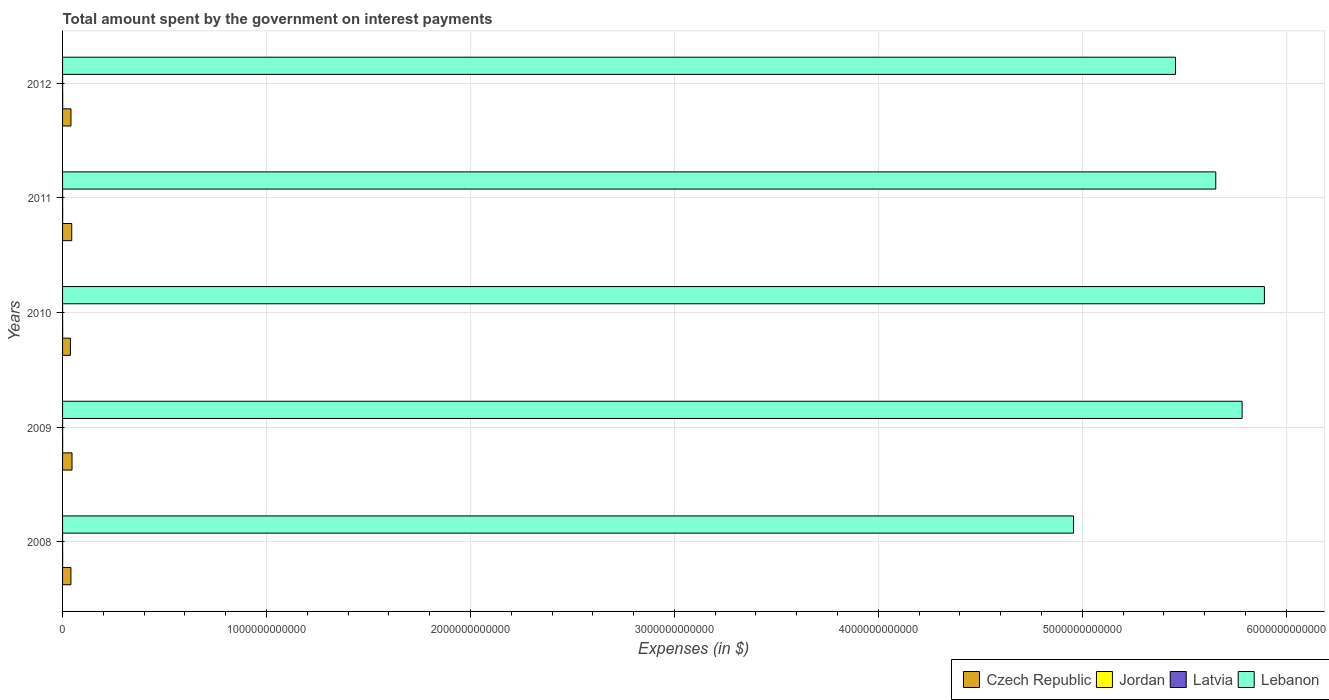How many different coloured bars are there?
Make the answer very short. 4. Are the number of bars on each tick of the Y-axis equal?
Make the answer very short. Yes. How many bars are there on the 1st tick from the bottom?
Offer a terse response. 4. In how many cases, is the number of bars for a given year not equal to the number of legend labels?
Keep it short and to the point. 0. What is the amount spent on interest payments by the government in Jordan in 2010?
Your answer should be compact. 3.98e+08. Across all years, what is the maximum amount spent on interest payments by the government in Latvia?
Offer a very short reply. 2.15e+08. Across all years, what is the minimum amount spent on interest payments by the government in Lebanon?
Give a very brief answer. 4.96e+12. In which year was the amount spent on interest payments by the government in Lebanon maximum?
Your answer should be very brief. 2010. What is the total amount spent on interest payments by the government in Jordan in the graph?
Provide a short and direct response. 2.18e+09. What is the difference between the amount spent on interest payments by the government in Latvia in 2011 and that in 2012?
Keep it short and to the point. -2.36e+07. What is the difference between the amount spent on interest payments by the government in Latvia in 2008 and the amount spent on interest payments by the government in Czech Republic in 2012?
Provide a succinct answer. -4.11e+1. What is the average amount spent on interest payments by the government in Latvia per year?
Ensure brevity in your answer.  1.56e+08. In the year 2008, what is the difference between the amount spent on interest payments by the government in Jordan and amount spent on interest payments by the government in Lebanon?
Provide a short and direct response. -4.96e+12. What is the ratio of the amount spent on interest payments by the government in Latvia in 2008 to that in 2010?
Offer a very short reply. 0.35. Is the difference between the amount spent on interest payments by the government in Jordan in 2009 and 2010 greater than the difference between the amount spent on interest payments by the government in Lebanon in 2009 and 2010?
Your response must be concise. Yes. What is the difference between the highest and the second highest amount spent on interest payments by the government in Latvia?
Give a very brief answer. 2.36e+07. What is the difference between the highest and the lowest amount spent on interest payments by the government in Lebanon?
Provide a short and direct response. 9.36e+11. In how many years, is the amount spent on interest payments by the government in Latvia greater than the average amount spent on interest payments by the government in Latvia taken over all years?
Provide a succinct answer. 3. Is the sum of the amount spent on interest payments by the government in Latvia in 2010 and 2012 greater than the maximum amount spent on interest payments by the government in Lebanon across all years?
Offer a very short reply. No. What does the 4th bar from the top in 2010 represents?
Offer a terse response. Czech Republic. What does the 4th bar from the bottom in 2009 represents?
Offer a terse response. Lebanon. Is it the case that in every year, the sum of the amount spent on interest payments by the government in Latvia and amount spent on interest payments by the government in Czech Republic is greater than the amount spent on interest payments by the government in Jordan?
Give a very brief answer. Yes. Are all the bars in the graph horizontal?
Ensure brevity in your answer.  Yes. What is the difference between two consecutive major ticks on the X-axis?
Your answer should be compact. 1.00e+12. Are the values on the major ticks of X-axis written in scientific E-notation?
Offer a very short reply. No. Does the graph contain grids?
Your answer should be compact. Yes. Where does the legend appear in the graph?
Offer a terse response. Bottom right. How many legend labels are there?
Your answer should be compact. 4. What is the title of the graph?
Make the answer very short. Total amount spent by the government on interest payments. Does "Macedonia" appear as one of the legend labels in the graph?
Your response must be concise. No. What is the label or title of the X-axis?
Make the answer very short. Expenses (in $). What is the Expenses (in $) in Czech Republic in 2008?
Your answer should be very brief. 4.09e+1. What is the Expenses (in $) of Jordan in 2008?
Your answer should be compact. 3.78e+08. What is the Expenses (in $) of Latvia in 2008?
Make the answer very short. 5.90e+07. What is the Expenses (in $) in Lebanon in 2008?
Offer a very short reply. 4.96e+12. What is the Expenses (in $) of Czech Republic in 2009?
Your answer should be compact. 4.64e+1. What is the Expenses (in $) of Jordan in 2009?
Your answer should be compact. 3.92e+08. What is the Expenses (in $) in Latvia in 2009?
Keep it short and to the point. 1.44e+08. What is the Expenses (in $) of Lebanon in 2009?
Your response must be concise. 5.78e+12. What is the Expenses (in $) of Czech Republic in 2010?
Offer a very short reply. 3.85e+1. What is the Expenses (in $) of Jordan in 2010?
Offer a terse response. 3.98e+08. What is the Expenses (in $) in Latvia in 2010?
Offer a terse response. 1.70e+08. What is the Expenses (in $) in Lebanon in 2010?
Offer a terse response. 5.89e+12. What is the Expenses (in $) in Czech Republic in 2011?
Provide a succinct answer. 4.50e+1. What is the Expenses (in $) in Jordan in 2011?
Give a very brief answer. 4.30e+08. What is the Expenses (in $) of Latvia in 2011?
Offer a terse response. 1.91e+08. What is the Expenses (in $) of Lebanon in 2011?
Keep it short and to the point. 5.65e+12. What is the Expenses (in $) of Czech Republic in 2012?
Keep it short and to the point. 4.12e+1. What is the Expenses (in $) in Jordan in 2012?
Ensure brevity in your answer.  5.83e+08. What is the Expenses (in $) of Latvia in 2012?
Provide a short and direct response. 2.15e+08. What is the Expenses (in $) in Lebanon in 2012?
Keep it short and to the point. 5.46e+12. Across all years, what is the maximum Expenses (in $) in Czech Republic?
Offer a terse response. 4.64e+1. Across all years, what is the maximum Expenses (in $) in Jordan?
Give a very brief answer. 5.83e+08. Across all years, what is the maximum Expenses (in $) in Latvia?
Your response must be concise. 2.15e+08. Across all years, what is the maximum Expenses (in $) in Lebanon?
Make the answer very short. 5.89e+12. Across all years, what is the minimum Expenses (in $) in Czech Republic?
Provide a succinct answer. 3.85e+1. Across all years, what is the minimum Expenses (in $) in Jordan?
Your response must be concise. 3.78e+08. Across all years, what is the minimum Expenses (in $) in Latvia?
Ensure brevity in your answer.  5.90e+07. Across all years, what is the minimum Expenses (in $) in Lebanon?
Give a very brief answer. 4.96e+12. What is the total Expenses (in $) of Czech Republic in the graph?
Keep it short and to the point. 2.12e+11. What is the total Expenses (in $) in Jordan in the graph?
Give a very brief answer. 2.18e+09. What is the total Expenses (in $) of Latvia in the graph?
Your answer should be very brief. 7.79e+08. What is the total Expenses (in $) of Lebanon in the graph?
Your answer should be compact. 2.77e+13. What is the difference between the Expenses (in $) of Czech Republic in 2008 and that in 2009?
Make the answer very short. -5.42e+09. What is the difference between the Expenses (in $) in Jordan in 2008 and that in 2009?
Offer a very short reply. -1.44e+07. What is the difference between the Expenses (in $) in Latvia in 2008 and that in 2009?
Your answer should be very brief. -8.50e+07. What is the difference between the Expenses (in $) of Lebanon in 2008 and that in 2009?
Give a very brief answer. -8.27e+11. What is the difference between the Expenses (in $) in Czech Republic in 2008 and that in 2010?
Your answer should be very brief. 2.45e+09. What is the difference between the Expenses (in $) of Jordan in 2008 and that in 2010?
Your answer should be very brief. -1.97e+07. What is the difference between the Expenses (in $) in Latvia in 2008 and that in 2010?
Your answer should be very brief. -1.11e+08. What is the difference between the Expenses (in $) of Lebanon in 2008 and that in 2010?
Provide a succinct answer. -9.36e+11. What is the difference between the Expenses (in $) of Czech Republic in 2008 and that in 2011?
Provide a succinct answer. -4.04e+09. What is the difference between the Expenses (in $) in Jordan in 2008 and that in 2011?
Make the answer very short. -5.17e+07. What is the difference between the Expenses (in $) in Latvia in 2008 and that in 2011?
Keep it short and to the point. -1.32e+08. What is the difference between the Expenses (in $) of Lebanon in 2008 and that in 2011?
Your answer should be compact. -6.97e+11. What is the difference between the Expenses (in $) in Czech Republic in 2008 and that in 2012?
Your answer should be compact. -2.34e+08. What is the difference between the Expenses (in $) in Jordan in 2008 and that in 2012?
Offer a very short reply. -2.05e+08. What is the difference between the Expenses (in $) in Latvia in 2008 and that in 2012?
Your response must be concise. -1.56e+08. What is the difference between the Expenses (in $) of Lebanon in 2008 and that in 2012?
Provide a short and direct response. -5.00e+11. What is the difference between the Expenses (in $) of Czech Republic in 2009 and that in 2010?
Keep it short and to the point. 7.87e+09. What is the difference between the Expenses (in $) of Jordan in 2009 and that in 2010?
Your answer should be very brief. -5.30e+06. What is the difference between the Expenses (in $) in Latvia in 2009 and that in 2010?
Offer a very short reply. -2.62e+07. What is the difference between the Expenses (in $) of Lebanon in 2009 and that in 2010?
Provide a short and direct response. -1.09e+11. What is the difference between the Expenses (in $) of Czech Republic in 2009 and that in 2011?
Keep it short and to the point. 1.38e+09. What is the difference between the Expenses (in $) of Jordan in 2009 and that in 2011?
Give a very brief answer. -3.73e+07. What is the difference between the Expenses (in $) in Latvia in 2009 and that in 2011?
Make the answer very short. -4.69e+07. What is the difference between the Expenses (in $) in Lebanon in 2009 and that in 2011?
Your answer should be very brief. 1.29e+11. What is the difference between the Expenses (in $) in Czech Republic in 2009 and that in 2012?
Offer a terse response. 5.19e+09. What is the difference between the Expenses (in $) of Jordan in 2009 and that in 2012?
Offer a terse response. -1.91e+08. What is the difference between the Expenses (in $) in Latvia in 2009 and that in 2012?
Make the answer very short. -7.05e+07. What is the difference between the Expenses (in $) in Lebanon in 2009 and that in 2012?
Your answer should be compact. 3.27e+11. What is the difference between the Expenses (in $) of Czech Republic in 2010 and that in 2011?
Provide a short and direct response. -6.49e+09. What is the difference between the Expenses (in $) of Jordan in 2010 and that in 2011?
Your answer should be compact. -3.20e+07. What is the difference between the Expenses (in $) in Latvia in 2010 and that in 2011?
Your answer should be very brief. -2.07e+07. What is the difference between the Expenses (in $) of Lebanon in 2010 and that in 2011?
Provide a short and direct response. 2.38e+11. What is the difference between the Expenses (in $) in Czech Republic in 2010 and that in 2012?
Ensure brevity in your answer.  -2.69e+09. What is the difference between the Expenses (in $) of Jordan in 2010 and that in 2012?
Your answer should be compact. -1.86e+08. What is the difference between the Expenses (in $) of Latvia in 2010 and that in 2012?
Keep it short and to the point. -4.43e+07. What is the difference between the Expenses (in $) in Lebanon in 2010 and that in 2012?
Your answer should be compact. 4.36e+11. What is the difference between the Expenses (in $) in Czech Republic in 2011 and that in 2012?
Give a very brief answer. 3.81e+09. What is the difference between the Expenses (in $) of Jordan in 2011 and that in 2012?
Your answer should be compact. -1.54e+08. What is the difference between the Expenses (in $) of Latvia in 2011 and that in 2012?
Your answer should be compact. -2.36e+07. What is the difference between the Expenses (in $) of Lebanon in 2011 and that in 2012?
Offer a very short reply. 1.98e+11. What is the difference between the Expenses (in $) of Czech Republic in 2008 and the Expenses (in $) of Jordan in 2009?
Provide a succinct answer. 4.06e+1. What is the difference between the Expenses (in $) of Czech Republic in 2008 and the Expenses (in $) of Latvia in 2009?
Your response must be concise. 4.08e+1. What is the difference between the Expenses (in $) in Czech Republic in 2008 and the Expenses (in $) in Lebanon in 2009?
Provide a succinct answer. -5.74e+12. What is the difference between the Expenses (in $) of Jordan in 2008 and the Expenses (in $) of Latvia in 2009?
Provide a short and direct response. 2.34e+08. What is the difference between the Expenses (in $) in Jordan in 2008 and the Expenses (in $) in Lebanon in 2009?
Your answer should be compact. -5.78e+12. What is the difference between the Expenses (in $) of Latvia in 2008 and the Expenses (in $) of Lebanon in 2009?
Ensure brevity in your answer.  -5.78e+12. What is the difference between the Expenses (in $) of Czech Republic in 2008 and the Expenses (in $) of Jordan in 2010?
Give a very brief answer. 4.05e+1. What is the difference between the Expenses (in $) in Czech Republic in 2008 and the Expenses (in $) in Latvia in 2010?
Your response must be concise. 4.08e+1. What is the difference between the Expenses (in $) in Czech Republic in 2008 and the Expenses (in $) in Lebanon in 2010?
Offer a very short reply. -5.85e+12. What is the difference between the Expenses (in $) in Jordan in 2008 and the Expenses (in $) in Latvia in 2010?
Provide a succinct answer. 2.08e+08. What is the difference between the Expenses (in $) in Jordan in 2008 and the Expenses (in $) in Lebanon in 2010?
Your response must be concise. -5.89e+12. What is the difference between the Expenses (in $) of Latvia in 2008 and the Expenses (in $) of Lebanon in 2010?
Provide a succinct answer. -5.89e+12. What is the difference between the Expenses (in $) in Czech Republic in 2008 and the Expenses (in $) in Jordan in 2011?
Your answer should be very brief. 4.05e+1. What is the difference between the Expenses (in $) of Czech Republic in 2008 and the Expenses (in $) of Latvia in 2011?
Your answer should be compact. 4.08e+1. What is the difference between the Expenses (in $) of Czech Republic in 2008 and the Expenses (in $) of Lebanon in 2011?
Provide a short and direct response. -5.61e+12. What is the difference between the Expenses (in $) of Jordan in 2008 and the Expenses (in $) of Latvia in 2011?
Your answer should be very brief. 1.87e+08. What is the difference between the Expenses (in $) in Jordan in 2008 and the Expenses (in $) in Lebanon in 2011?
Provide a short and direct response. -5.65e+12. What is the difference between the Expenses (in $) of Latvia in 2008 and the Expenses (in $) of Lebanon in 2011?
Ensure brevity in your answer.  -5.65e+12. What is the difference between the Expenses (in $) in Czech Republic in 2008 and the Expenses (in $) in Jordan in 2012?
Provide a short and direct response. 4.04e+1. What is the difference between the Expenses (in $) in Czech Republic in 2008 and the Expenses (in $) in Latvia in 2012?
Your answer should be very brief. 4.07e+1. What is the difference between the Expenses (in $) of Czech Republic in 2008 and the Expenses (in $) of Lebanon in 2012?
Your answer should be very brief. -5.42e+12. What is the difference between the Expenses (in $) of Jordan in 2008 and the Expenses (in $) of Latvia in 2012?
Give a very brief answer. 1.63e+08. What is the difference between the Expenses (in $) of Jordan in 2008 and the Expenses (in $) of Lebanon in 2012?
Ensure brevity in your answer.  -5.46e+12. What is the difference between the Expenses (in $) in Latvia in 2008 and the Expenses (in $) in Lebanon in 2012?
Your answer should be very brief. -5.46e+12. What is the difference between the Expenses (in $) in Czech Republic in 2009 and the Expenses (in $) in Jordan in 2010?
Keep it short and to the point. 4.60e+1. What is the difference between the Expenses (in $) in Czech Republic in 2009 and the Expenses (in $) in Latvia in 2010?
Keep it short and to the point. 4.62e+1. What is the difference between the Expenses (in $) of Czech Republic in 2009 and the Expenses (in $) of Lebanon in 2010?
Provide a short and direct response. -5.85e+12. What is the difference between the Expenses (in $) in Jordan in 2009 and the Expenses (in $) in Latvia in 2010?
Your answer should be compact. 2.22e+08. What is the difference between the Expenses (in $) in Jordan in 2009 and the Expenses (in $) in Lebanon in 2010?
Your answer should be very brief. -5.89e+12. What is the difference between the Expenses (in $) in Latvia in 2009 and the Expenses (in $) in Lebanon in 2010?
Your response must be concise. -5.89e+12. What is the difference between the Expenses (in $) in Czech Republic in 2009 and the Expenses (in $) in Jordan in 2011?
Give a very brief answer. 4.59e+1. What is the difference between the Expenses (in $) in Czech Republic in 2009 and the Expenses (in $) in Latvia in 2011?
Keep it short and to the point. 4.62e+1. What is the difference between the Expenses (in $) in Czech Republic in 2009 and the Expenses (in $) in Lebanon in 2011?
Offer a very short reply. -5.61e+12. What is the difference between the Expenses (in $) in Jordan in 2009 and the Expenses (in $) in Latvia in 2011?
Keep it short and to the point. 2.01e+08. What is the difference between the Expenses (in $) in Jordan in 2009 and the Expenses (in $) in Lebanon in 2011?
Keep it short and to the point. -5.65e+12. What is the difference between the Expenses (in $) of Latvia in 2009 and the Expenses (in $) of Lebanon in 2011?
Keep it short and to the point. -5.65e+12. What is the difference between the Expenses (in $) of Czech Republic in 2009 and the Expenses (in $) of Jordan in 2012?
Give a very brief answer. 4.58e+1. What is the difference between the Expenses (in $) in Czech Republic in 2009 and the Expenses (in $) in Latvia in 2012?
Your response must be concise. 4.62e+1. What is the difference between the Expenses (in $) of Czech Republic in 2009 and the Expenses (in $) of Lebanon in 2012?
Offer a terse response. -5.41e+12. What is the difference between the Expenses (in $) of Jordan in 2009 and the Expenses (in $) of Latvia in 2012?
Keep it short and to the point. 1.78e+08. What is the difference between the Expenses (in $) in Jordan in 2009 and the Expenses (in $) in Lebanon in 2012?
Give a very brief answer. -5.46e+12. What is the difference between the Expenses (in $) in Latvia in 2009 and the Expenses (in $) in Lebanon in 2012?
Ensure brevity in your answer.  -5.46e+12. What is the difference between the Expenses (in $) in Czech Republic in 2010 and the Expenses (in $) in Jordan in 2011?
Give a very brief answer. 3.81e+1. What is the difference between the Expenses (in $) of Czech Republic in 2010 and the Expenses (in $) of Latvia in 2011?
Provide a succinct answer. 3.83e+1. What is the difference between the Expenses (in $) of Czech Republic in 2010 and the Expenses (in $) of Lebanon in 2011?
Ensure brevity in your answer.  -5.62e+12. What is the difference between the Expenses (in $) in Jordan in 2010 and the Expenses (in $) in Latvia in 2011?
Your answer should be compact. 2.07e+08. What is the difference between the Expenses (in $) in Jordan in 2010 and the Expenses (in $) in Lebanon in 2011?
Offer a terse response. -5.65e+12. What is the difference between the Expenses (in $) in Latvia in 2010 and the Expenses (in $) in Lebanon in 2011?
Give a very brief answer. -5.65e+12. What is the difference between the Expenses (in $) of Czech Republic in 2010 and the Expenses (in $) of Jordan in 2012?
Provide a short and direct response. 3.79e+1. What is the difference between the Expenses (in $) of Czech Republic in 2010 and the Expenses (in $) of Latvia in 2012?
Make the answer very short. 3.83e+1. What is the difference between the Expenses (in $) of Czech Republic in 2010 and the Expenses (in $) of Lebanon in 2012?
Your answer should be very brief. -5.42e+12. What is the difference between the Expenses (in $) in Jordan in 2010 and the Expenses (in $) in Latvia in 2012?
Give a very brief answer. 1.83e+08. What is the difference between the Expenses (in $) of Jordan in 2010 and the Expenses (in $) of Lebanon in 2012?
Your answer should be very brief. -5.46e+12. What is the difference between the Expenses (in $) in Latvia in 2010 and the Expenses (in $) in Lebanon in 2012?
Your answer should be very brief. -5.46e+12. What is the difference between the Expenses (in $) in Czech Republic in 2011 and the Expenses (in $) in Jordan in 2012?
Keep it short and to the point. 4.44e+1. What is the difference between the Expenses (in $) in Czech Republic in 2011 and the Expenses (in $) in Latvia in 2012?
Give a very brief answer. 4.48e+1. What is the difference between the Expenses (in $) of Czech Republic in 2011 and the Expenses (in $) of Lebanon in 2012?
Make the answer very short. -5.41e+12. What is the difference between the Expenses (in $) of Jordan in 2011 and the Expenses (in $) of Latvia in 2012?
Make the answer very short. 2.15e+08. What is the difference between the Expenses (in $) in Jordan in 2011 and the Expenses (in $) in Lebanon in 2012?
Your answer should be compact. -5.46e+12. What is the difference between the Expenses (in $) of Latvia in 2011 and the Expenses (in $) of Lebanon in 2012?
Ensure brevity in your answer.  -5.46e+12. What is the average Expenses (in $) in Czech Republic per year?
Keep it short and to the point. 4.24e+1. What is the average Expenses (in $) of Jordan per year?
Keep it short and to the point. 4.36e+08. What is the average Expenses (in $) in Latvia per year?
Your response must be concise. 1.56e+08. What is the average Expenses (in $) in Lebanon per year?
Keep it short and to the point. 5.55e+12. In the year 2008, what is the difference between the Expenses (in $) of Czech Republic and Expenses (in $) of Jordan?
Provide a short and direct response. 4.06e+1. In the year 2008, what is the difference between the Expenses (in $) in Czech Republic and Expenses (in $) in Latvia?
Keep it short and to the point. 4.09e+1. In the year 2008, what is the difference between the Expenses (in $) in Czech Republic and Expenses (in $) in Lebanon?
Offer a very short reply. -4.92e+12. In the year 2008, what is the difference between the Expenses (in $) of Jordan and Expenses (in $) of Latvia?
Give a very brief answer. 3.19e+08. In the year 2008, what is the difference between the Expenses (in $) in Jordan and Expenses (in $) in Lebanon?
Make the answer very short. -4.96e+12. In the year 2008, what is the difference between the Expenses (in $) of Latvia and Expenses (in $) of Lebanon?
Make the answer very short. -4.96e+12. In the year 2009, what is the difference between the Expenses (in $) of Czech Republic and Expenses (in $) of Jordan?
Ensure brevity in your answer.  4.60e+1. In the year 2009, what is the difference between the Expenses (in $) in Czech Republic and Expenses (in $) in Latvia?
Offer a very short reply. 4.62e+1. In the year 2009, what is the difference between the Expenses (in $) of Czech Republic and Expenses (in $) of Lebanon?
Your answer should be very brief. -5.74e+12. In the year 2009, what is the difference between the Expenses (in $) in Jordan and Expenses (in $) in Latvia?
Your answer should be very brief. 2.48e+08. In the year 2009, what is the difference between the Expenses (in $) in Jordan and Expenses (in $) in Lebanon?
Your answer should be compact. -5.78e+12. In the year 2009, what is the difference between the Expenses (in $) of Latvia and Expenses (in $) of Lebanon?
Give a very brief answer. -5.78e+12. In the year 2010, what is the difference between the Expenses (in $) of Czech Republic and Expenses (in $) of Jordan?
Provide a short and direct response. 3.81e+1. In the year 2010, what is the difference between the Expenses (in $) in Czech Republic and Expenses (in $) in Latvia?
Ensure brevity in your answer.  3.83e+1. In the year 2010, what is the difference between the Expenses (in $) of Czech Republic and Expenses (in $) of Lebanon?
Provide a short and direct response. -5.85e+12. In the year 2010, what is the difference between the Expenses (in $) in Jordan and Expenses (in $) in Latvia?
Your response must be concise. 2.27e+08. In the year 2010, what is the difference between the Expenses (in $) in Jordan and Expenses (in $) in Lebanon?
Offer a very short reply. -5.89e+12. In the year 2010, what is the difference between the Expenses (in $) of Latvia and Expenses (in $) of Lebanon?
Give a very brief answer. -5.89e+12. In the year 2011, what is the difference between the Expenses (in $) in Czech Republic and Expenses (in $) in Jordan?
Your response must be concise. 4.46e+1. In the year 2011, what is the difference between the Expenses (in $) of Czech Republic and Expenses (in $) of Latvia?
Give a very brief answer. 4.48e+1. In the year 2011, what is the difference between the Expenses (in $) in Czech Republic and Expenses (in $) in Lebanon?
Your answer should be very brief. -5.61e+12. In the year 2011, what is the difference between the Expenses (in $) in Jordan and Expenses (in $) in Latvia?
Your answer should be compact. 2.39e+08. In the year 2011, what is the difference between the Expenses (in $) of Jordan and Expenses (in $) of Lebanon?
Provide a succinct answer. -5.65e+12. In the year 2011, what is the difference between the Expenses (in $) of Latvia and Expenses (in $) of Lebanon?
Your response must be concise. -5.65e+12. In the year 2012, what is the difference between the Expenses (in $) in Czech Republic and Expenses (in $) in Jordan?
Ensure brevity in your answer.  4.06e+1. In the year 2012, what is the difference between the Expenses (in $) in Czech Republic and Expenses (in $) in Latvia?
Make the answer very short. 4.10e+1. In the year 2012, what is the difference between the Expenses (in $) in Czech Republic and Expenses (in $) in Lebanon?
Keep it short and to the point. -5.42e+12. In the year 2012, what is the difference between the Expenses (in $) in Jordan and Expenses (in $) in Latvia?
Your response must be concise. 3.68e+08. In the year 2012, what is the difference between the Expenses (in $) in Jordan and Expenses (in $) in Lebanon?
Keep it short and to the point. -5.46e+12. In the year 2012, what is the difference between the Expenses (in $) of Latvia and Expenses (in $) of Lebanon?
Make the answer very short. -5.46e+12. What is the ratio of the Expenses (in $) in Czech Republic in 2008 to that in 2009?
Provide a succinct answer. 0.88. What is the ratio of the Expenses (in $) in Jordan in 2008 to that in 2009?
Provide a succinct answer. 0.96. What is the ratio of the Expenses (in $) of Latvia in 2008 to that in 2009?
Your answer should be very brief. 0.41. What is the ratio of the Expenses (in $) in Czech Republic in 2008 to that in 2010?
Keep it short and to the point. 1.06. What is the ratio of the Expenses (in $) of Jordan in 2008 to that in 2010?
Your answer should be compact. 0.95. What is the ratio of the Expenses (in $) in Latvia in 2008 to that in 2010?
Your answer should be compact. 0.35. What is the ratio of the Expenses (in $) of Lebanon in 2008 to that in 2010?
Offer a very short reply. 0.84. What is the ratio of the Expenses (in $) in Czech Republic in 2008 to that in 2011?
Ensure brevity in your answer.  0.91. What is the ratio of the Expenses (in $) of Jordan in 2008 to that in 2011?
Provide a succinct answer. 0.88. What is the ratio of the Expenses (in $) in Latvia in 2008 to that in 2011?
Make the answer very short. 0.31. What is the ratio of the Expenses (in $) of Lebanon in 2008 to that in 2011?
Your answer should be very brief. 0.88. What is the ratio of the Expenses (in $) of Czech Republic in 2008 to that in 2012?
Give a very brief answer. 0.99. What is the ratio of the Expenses (in $) in Jordan in 2008 to that in 2012?
Your answer should be very brief. 0.65. What is the ratio of the Expenses (in $) of Latvia in 2008 to that in 2012?
Provide a short and direct response. 0.28. What is the ratio of the Expenses (in $) of Lebanon in 2008 to that in 2012?
Keep it short and to the point. 0.91. What is the ratio of the Expenses (in $) in Czech Republic in 2009 to that in 2010?
Make the answer very short. 1.2. What is the ratio of the Expenses (in $) in Jordan in 2009 to that in 2010?
Your response must be concise. 0.99. What is the ratio of the Expenses (in $) of Latvia in 2009 to that in 2010?
Provide a short and direct response. 0.85. What is the ratio of the Expenses (in $) of Lebanon in 2009 to that in 2010?
Make the answer very short. 0.98. What is the ratio of the Expenses (in $) in Czech Republic in 2009 to that in 2011?
Your answer should be very brief. 1.03. What is the ratio of the Expenses (in $) of Jordan in 2009 to that in 2011?
Offer a terse response. 0.91. What is the ratio of the Expenses (in $) of Latvia in 2009 to that in 2011?
Your answer should be very brief. 0.75. What is the ratio of the Expenses (in $) of Lebanon in 2009 to that in 2011?
Your response must be concise. 1.02. What is the ratio of the Expenses (in $) in Czech Republic in 2009 to that in 2012?
Offer a terse response. 1.13. What is the ratio of the Expenses (in $) of Jordan in 2009 to that in 2012?
Your response must be concise. 0.67. What is the ratio of the Expenses (in $) in Latvia in 2009 to that in 2012?
Offer a very short reply. 0.67. What is the ratio of the Expenses (in $) of Lebanon in 2009 to that in 2012?
Make the answer very short. 1.06. What is the ratio of the Expenses (in $) in Czech Republic in 2010 to that in 2011?
Make the answer very short. 0.86. What is the ratio of the Expenses (in $) in Jordan in 2010 to that in 2011?
Ensure brevity in your answer.  0.93. What is the ratio of the Expenses (in $) in Latvia in 2010 to that in 2011?
Offer a very short reply. 0.89. What is the ratio of the Expenses (in $) of Lebanon in 2010 to that in 2011?
Ensure brevity in your answer.  1.04. What is the ratio of the Expenses (in $) of Czech Republic in 2010 to that in 2012?
Make the answer very short. 0.93. What is the ratio of the Expenses (in $) in Jordan in 2010 to that in 2012?
Make the answer very short. 0.68. What is the ratio of the Expenses (in $) in Latvia in 2010 to that in 2012?
Your answer should be compact. 0.79. What is the ratio of the Expenses (in $) of Lebanon in 2010 to that in 2012?
Keep it short and to the point. 1.08. What is the ratio of the Expenses (in $) of Czech Republic in 2011 to that in 2012?
Provide a succinct answer. 1.09. What is the ratio of the Expenses (in $) in Jordan in 2011 to that in 2012?
Offer a terse response. 0.74. What is the ratio of the Expenses (in $) in Latvia in 2011 to that in 2012?
Provide a succinct answer. 0.89. What is the ratio of the Expenses (in $) in Lebanon in 2011 to that in 2012?
Provide a succinct answer. 1.04. What is the difference between the highest and the second highest Expenses (in $) in Czech Republic?
Make the answer very short. 1.38e+09. What is the difference between the highest and the second highest Expenses (in $) of Jordan?
Offer a terse response. 1.54e+08. What is the difference between the highest and the second highest Expenses (in $) in Latvia?
Give a very brief answer. 2.36e+07. What is the difference between the highest and the second highest Expenses (in $) in Lebanon?
Your response must be concise. 1.09e+11. What is the difference between the highest and the lowest Expenses (in $) in Czech Republic?
Offer a very short reply. 7.87e+09. What is the difference between the highest and the lowest Expenses (in $) in Jordan?
Provide a succinct answer. 2.05e+08. What is the difference between the highest and the lowest Expenses (in $) of Latvia?
Provide a short and direct response. 1.56e+08. What is the difference between the highest and the lowest Expenses (in $) in Lebanon?
Make the answer very short. 9.36e+11. 